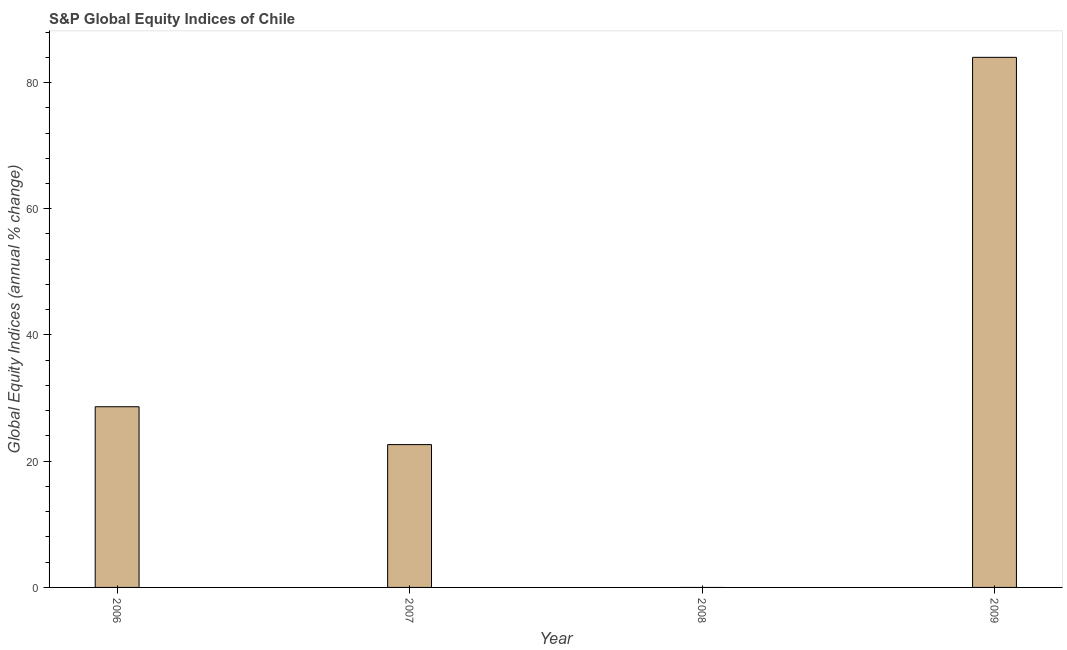Does the graph contain grids?
Your response must be concise. No. What is the title of the graph?
Provide a short and direct response. S&P Global Equity Indices of Chile. What is the label or title of the X-axis?
Give a very brief answer. Year. What is the label or title of the Y-axis?
Make the answer very short. Global Equity Indices (annual % change). What is the s&p global equity indices in 2009?
Offer a very short reply. 83.99. Across all years, what is the maximum s&p global equity indices?
Provide a short and direct response. 83.99. Across all years, what is the minimum s&p global equity indices?
Your answer should be compact. 0. In which year was the s&p global equity indices maximum?
Make the answer very short. 2009. What is the sum of the s&p global equity indices?
Offer a terse response. 135.25. What is the difference between the s&p global equity indices in 2007 and 2009?
Ensure brevity in your answer.  -61.36. What is the average s&p global equity indices per year?
Ensure brevity in your answer.  33.81. What is the median s&p global equity indices?
Offer a terse response. 25.63. What is the ratio of the s&p global equity indices in 2006 to that in 2007?
Provide a short and direct response. 1.26. What is the difference between the highest and the second highest s&p global equity indices?
Your response must be concise. 55.36. What is the difference between the highest and the lowest s&p global equity indices?
Give a very brief answer. 83.99. How many years are there in the graph?
Provide a short and direct response. 4. Are the values on the major ticks of Y-axis written in scientific E-notation?
Offer a very short reply. No. What is the Global Equity Indices (annual % change) of 2006?
Your answer should be very brief. 28.63. What is the Global Equity Indices (annual % change) of 2007?
Give a very brief answer. 22.63. What is the Global Equity Indices (annual % change) of 2009?
Your answer should be compact. 83.99. What is the difference between the Global Equity Indices (annual % change) in 2006 and 2007?
Provide a short and direct response. 6. What is the difference between the Global Equity Indices (annual % change) in 2006 and 2009?
Give a very brief answer. -55.36. What is the difference between the Global Equity Indices (annual % change) in 2007 and 2009?
Offer a terse response. -61.36. What is the ratio of the Global Equity Indices (annual % change) in 2006 to that in 2007?
Offer a terse response. 1.26. What is the ratio of the Global Equity Indices (annual % change) in 2006 to that in 2009?
Provide a succinct answer. 0.34. What is the ratio of the Global Equity Indices (annual % change) in 2007 to that in 2009?
Keep it short and to the point. 0.27. 